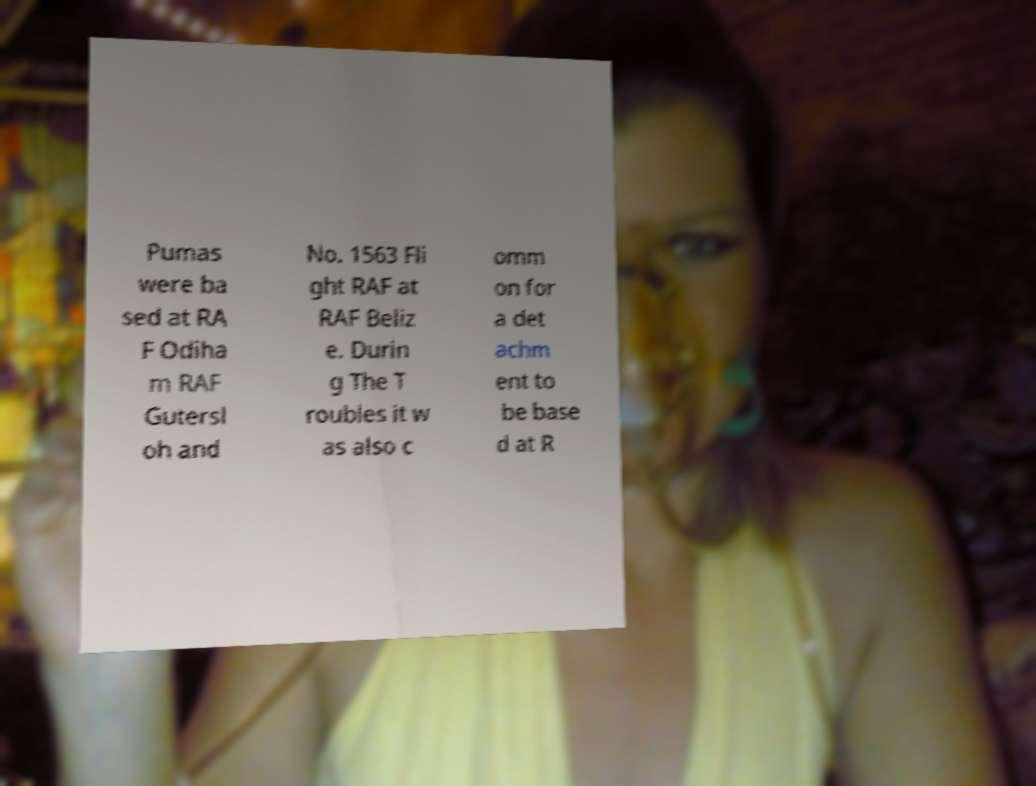Could you assist in decoding the text presented in this image and type it out clearly? Pumas were ba sed at RA F Odiha m RAF Gutersl oh and No. 1563 Fli ght RAF at RAF Beliz e. Durin g The T roubles it w as also c omm on for a det achm ent to be base d at R 